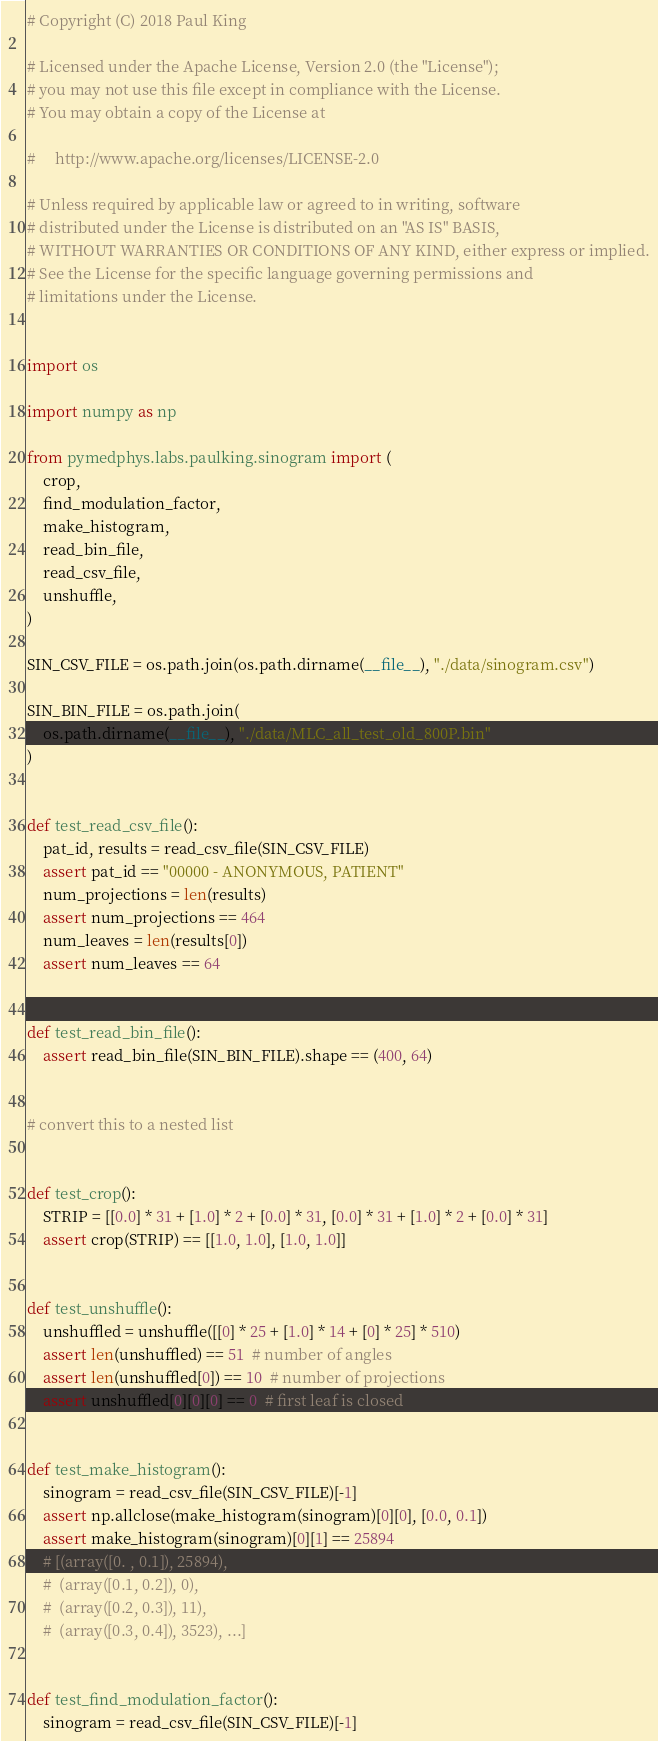<code> <loc_0><loc_0><loc_500><loc_500><_Python_># Copyright (C) 2018 Paul King

# Licensed under the Apache License, Version 2.0 (the "License");
# you may not use this file except in compliance with the License.
# You may obtain a copy of the License at

#     http://www.apache.org/licenses/LICENSE-2.0

# Unless required by applicable law or agreed to in writing, software
# distributed under the License is distributed on an "AS IS" BASIS,
# WITHOUT WARRANTIES OR CONDITIONS OF ANY KIND, either express or implied.
# See the License for the specific language governing permissions and
# limitations under the License.


import os

import numpy as np

from pymedphys.labs.paulking.sinogram import (
    crop,
    find_modulation_factor,
    make_histogram,
    read_bin_file,
    read_csv_file,
    unshuffle,
)

SIN_CSV_FILE = os.path.join(os.path.dirname(__file__), "./data/sinogram.csv")

SIN_BIN_FILE = os.path.join(
    os.path.dirname(__file__), "./data/MLC_all_test_old_800P.bin"
)


def test_read_csv_file():
    pat_id, results = read_csv_file(SIN_CSV_FILE)
    assert pat_id == "00000 - ANONYMOUS, PATIENT"
    num_projections = len(results)
    assert num_projections == 464
    num_leaves = len(results[0])
    assert num_leaves == 64


def test_read_bin_file():
    assert read_bin_file(SIN_BIN_FILE).shape == (400, 64)


# convert this to a nested list


def test_crop():
    STRIP = [[0.0] * 31 + [1.0] * 2 + [0.0] * 31, [0.0] * 31 + [1.0] * 2 + [0.0] * 31]
    assert crop(STRIP) == [[1.0, 1.0], [1.0, 1.0]]


def test_unshuffle():
    unshuffled = unshuffle([[0] * 25 + [1.0] * 14 + [0] * 25] * 510)
    assert len(unshuffled) == 51  # number of angles
    assert len(unshuffled[0]) == 10  # number of projections
    assert unshuffled[0][0][0] == 0  # first leaf is closed


def test_make_histogram():
    sinogram = read_csv_file(SIN_CSV_FILE)[-1]
    assert np.allclose(make_histogram(sinogram)[0][0], [0.0, 0.1])
    assert make_histogram(sinogram)[0][1] == 25894
    # [(array([0. , 0.1]), 25894),
    #  (array([0.1, 0.2]), 0),
    #  (array([0.2, 0.3]), 11),
    #  (array([0.3, 0.4]), 3523), ...]


def test_find_modulation_factor():
    sinogram = read_csv_file(SIN_CSV_FILE)[-1]</code> 